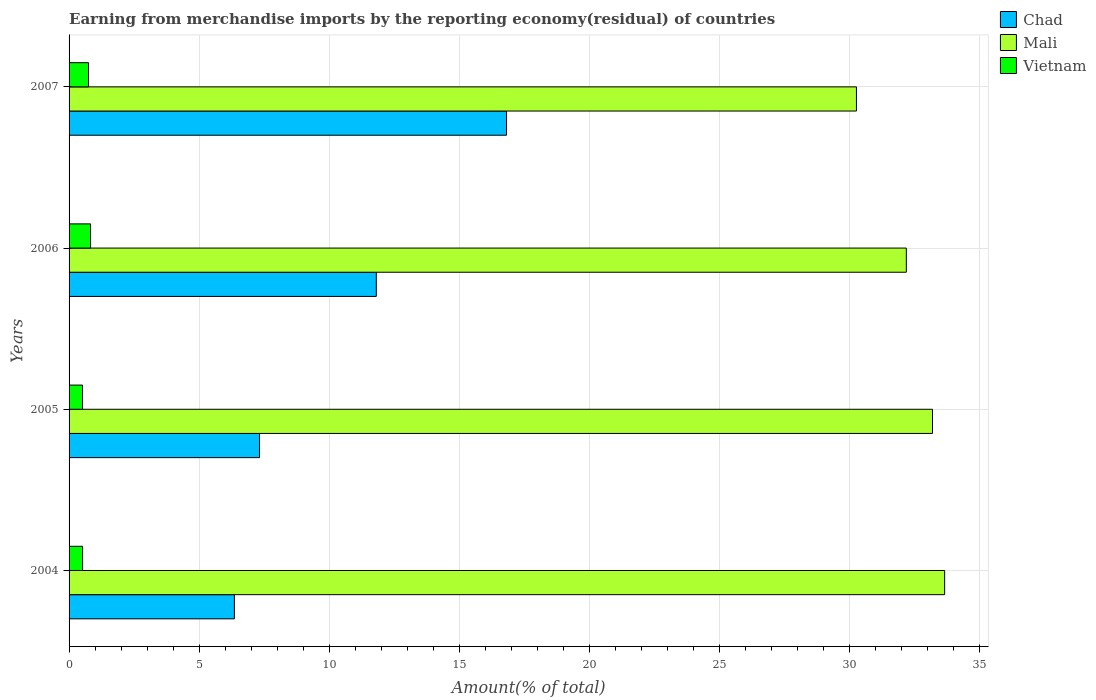How many groups of bars are there?
Your answer should be compact. 4. Are the number of bars per tick equal to the number of legend labels?
Your response must be concise. Yes. Are the number of bars on each tick of the Y-axis equal?
Ensure brevity in your answer.  Yes. In how many cases, is the number of bars for a given year not equal to the number of legend labels?
Ensure brevity in your answer.  0. What is the percentage of amount earned from merchandise imports in Chad in 2005?
Provide a short and direct response. 7.32. Across all years, what is the maximum percentage of amount earned from merchandise imports in Chad?
Offer a very short reply. 16.82. Across all years, what is the minimum percentage of amount earned from merchandise imports in Vietnam?
Your answer should be compact. 0.52. What is the total percentage of amount earned from merchandise imports in Chad in the graph?
Make the answer very short. 42.3. What is the difference between the percentage of amount earned from merchandise imports in Mali in 2004 and that in 2006?
Offer a very short reply. 1.47. What is the difference between the percentage of amount earned from merchandise imports in Chad in 2004 and the percentage of amount earned from merchandise imports in Mali in 2007?
Your response must be concise. -23.91. What is the average percentage of amount earned from merchandise imports in Vietnam per year?
Your response must be concise. 0.65. In the year 2004, what is the difference between the percentage of amount earned from merchandise imports in Mali and percentage of amount earned from merchandise imports in Chad?
Offer a very short reply. 27.3. What is the ratio of the percentage of amount earned from merchandise imports in Chad in 2006 to that in 2007?
Keep it short and to the point. 0.7. Is the percentage of amount earned from merchandise imports in Vietnam in 2004 less than that in 2006?
Provide a short and direct response. Yes. Is the difference between the percentage of amount earned from merchandise imports in Mali in 2005 and 2006 greater than the difference between the percentage of amount earned from merchandise imports in Chad in 2005 and 2006?
Keep it short and to the point. Yes. What is the difference between the highest and the second highest percentage of amount earned from merchandise imports in Vietnam?
Your answer should be compact. 0.08. What is the difference between the highest and the lowest percentage of amount earned from merchandise imports in Vietnam?
Your answer should be compact. 0.31. Is the sum of the percentage of amount earned from merchandise imports in Mali in 2005 and 2007 greater than the maximum percentage of amount earned from merchandise imports in Vietnam across all years?
Ensure brevity in your answer.  Yes. What does the 2nd bar from the top in 2004 represents?
Provide a short and direct response. Mali. What does the 3rd bar from the bottom in 2006 represents?
Your answer should be very brief. Vietnam. How many bars are there?
Offer a very short reply. 12. Are all the bars in the graph horizontal?
Provide a succinct answer. Yes. Are the values on the major ticks of X-axis written in scientific E-notation?
Provide a short and direct response. No. Does the graph contain grids?
Offer a very short reply. Yes. How many legend labels are there?
Provide a short and direct response. 3. How are the legend labels stacked?
Give a very brief answer. Vertical. What is the title of the graph?
Ensure brevity in your answer.  Earning from merchandise imports by the reporting economy(residual) of countries. Does "Liechtenstein" appear as one of the legend labels in the graph?
Offer a very short reply. No. What is the label or title of the X-axis?
Offer a terse response. Amount(% of total). What is the label or title of the Y-axis?
Offer a very short reply. Years. What is the Amount(% of total) in Chad in 2004?
Provide a short and direct response. 6.35. What is the Amount(% of total) in Mali in 2004?
Provide a succinct answer. 33.65. What is the Amount(% of total) in Vietnam in 2004?
Your answer should be compact. 0.52. What is the Amount(% of total) in Chad in 2005?
Keep it short and to the point. 7.32. What is the Amount(% of total) in Mali in 2005?
Provide a succinct answer. 33.19. What is the Amount(% of total) of Vietnam in 2005?
Your answer should be very brief. 0.52. What is the Amount(% of total) of Chad in 2006?
Your answer should be compact. 11.81. What is the Amount(% of total) in Mali in 2006?
Keep it short and to the point. 32.18. What is the Amount(% of total) of Vietnam in 2006?
Your answer should be compact. 0.83. What is the Amount(% of total) in Chad in 2007?
Ensure brevity in your answer.  16.82. What is the Amount(% of total) of Mali in 2007?
Make the answer very short. 30.26. What is the Amount(% of total) of Vietnam in 2007?
Your answer should be compact. 0.75. Across all years, what is the maximum Amount(% of total) in Chad?
Your response must be concise. 16.82. Across all years, what is the maximum Amount(% of total) of Mali?
Give a very brief answer. 33.65. Across all years, what is the maximum Amount(% of total) in Vietnam?
Provide a succinct answer. 0.83. Across all years, what is the minimum Amount(% of total) of Chad?
Provide a short and direct response. 6.35. Across all years, what is the minimum Amount(% of total) in Mali?
Keep it short and to the point. 30.26. Across all years, what is the minimum Amount(% of total) in Vietnam?
Your response must be concise. 0.52. What is the total Amount(% of total) in Chad in the graph?
Your answer should be very brief. 42.3. What is the total Amount(% of total) in Mali in the graph?
Offer a terse response. 129.29. What is the total Amount(% of total) of Vietnam in the graph?
Provide a succinct answer. 2.61. What is the difference between the Amount(% of total) in Chad in 2004 and that in 2005?
Your answer should be very brief. -0.97. What is the difference between the Amount(% of total) of Mali in 2004 and that in 2005?
Provide a succinct answer. 0.47. What is the difference between the Amount(% of total) in Vietnam in 2004 and that in 2005?
Give a very brief answer. 0. What is the difference between the Amount(% of total) of Chad in 2004 and that in 2006?
Make the answer very short. -5.46. What is the difference between the Amount(% of total) of Mali in 2004 and that in 2006?
Your answer should be very brief. 1.47. What is the difference between the Amount(% of total) of Vietnam in 2004 and that in 2006?
Provide a succinct answer. -0.31. What is the difference between the Amount(% of total) of Chad in 2004 and that in 2007?
Give a very brief answer. -10.46. What is the difference between the Amount(% of total) in Mali in 2004 and that in 2007?
Make the answer very short. 3.39. What is the difference between the Amount(% of total) in Vietnam in 2004 and that in 2007?
Your answer should be very brief. -0.23. What is the difference between the Amount(% of total) in Chad in 2005 and that in 2006?
Ensure brevity in your answer.  -4.49. What is the difference between the Amount(% of total) in Mali in 2005 and that in 2006?
Provide a succinct answer. 1.01. What is the difference between the Amount(% of total) in Vietnam in 2005 and that in 2006?
Make the answer very short. -0.31. What is the difference between the Amount(% of total) in Chad in 2005 and that in 2007?
Your response must be concise. -9.5. What is the difference between the Amount(% of total) of Mali in 2005 and that in 2007?
Give a very brief answer. 2.92. What is the difference between the Amount(% of total) in Vietnam in 2005 and that in 2007?
Offer a very short reply. -0.23. What is the difference between the Amount(% of total) of Chad in 2006 and that in 2007?
Keep it short and to the point. -5.01. What is the difference between the Amount(% of total) in Mali in 2006 and that in 2007?
Offer a terse response. 1.92. What is the difference between the Amount(% of total) in Vietnam in 2006 and that in 2007?
Your answer should be compact. 0.08. What is the difference between the Amount(% of total) of Chad in 2004 and the Amount(% of total) of Mali in 2005?
Ensure brevity in your answer.  -26.83. What is the difference between the Amount(% of total) in Chad in 2004 and the Amount(% of total) in Vietnam in 2005?
Provide a short and direct response. 5.84. What is the difference between the Amount(% of total) of Mali in 2004 and the Amount(% of total) of Vietnam in 2005?
Offer a very short reply. 33.14. What is the difference between the Amount(% of total) of Chad in 2004 and the Amount(% of total) of Mali in 2006?
Offer a terse response. -25.83. What is the difference between the Amount(% of total) in Chad in 2004 and the Amount(% of total) in Vietnam in 2006?
Your answer should be compact. 5.53. What is the difference between the Amount(% of total) in Mali in 2004 and the Amount(% of total) in Vietnam in 2006?
Offer a terse response. 32.83. What is the difference between the Amount(% of total) in Chad in 2004 and the Amount(% of total) in Mali in 2007?
Provide a succinct answer. -23.91. What is the difference between the Amount(% of total) in Chad in 2004 and the Amount(% of total) in Vietnam in 2007?
Give a very brief answer. 5.61. What is the difference between the Amount(% of total) of Mali in 2004 and the Amount(% of total) of Vietnam in 2007?
Your response must be concise. 32.91. What is the difference between the Amount(% of total) of Chad in 2005 and the Amount(% of total) of Mali in 2006?
Offer a very short reply. -24.86. What is the difference between the Amount(% of total) in Chad in 2005 and the Amount(% of total) in Vietnam in 2006?
Provide a succinct answer. 6.49. What is the difference between the Amount(% of total) of Mali in 2005 and the Amount(% of total) of Vietnam in 2006?
Offer a very short reply. 32.36. What is the difference between the Amount(% of total) of Chad in 2005 and the Amount(% of total) of Mali in 2007?
Provide a short and direct response. -22.94. What is the difference between the Amount(% of total) in Chad in 2005 and the Amount(% of total) in Vietnam in 2007?
Your answer should be compact. 6.57. What is the difference between the Amount(% of total) in Mali in 2005 and the Amount(% of total) in Vietnam in 2007?
Provide a succinct answer. 32.44. What is the difference between the Amount(% of total) of Chad in 2006 and the Amount(% of total) of Mali in 2007?
Provide a short and direct response. -18.45. What is the difference between the Amount(% of total) of Chad in 2006 and the Amount(% of total) of Vietnam in 2007?
Offer a very short reply. 11.06. What is the difference between the Amount(% of total) in Mali in 2006 and the Amount(% of total) in Vietnam in 2007?
Provide a short and direct response. 31.43. What is the average Amount(% of total) of Chad per year?
Provide a short and direct response. 10.57. What is the average Amount(% of total) in Mali per year?
Offer a terse response. 32.32. What is the average Amount(% of total) in Vietnam per year?
Your response must be concise. 0.65. In the year 2004, what is the difference between the Amount(% of total) in Chad and Amount(% of total) in Mali?
Offer a very short reply. -27.3. In the year 2004, what is the difference between the Amount(% of total) in Chad and Amount(% of total) in Vietnam?
Your response must be concise. 5.83. In the year 2004, what is the difference between the Amount(% of total) of Mali and Amount(% of total) of Vietnam?
Provide a short and direct response. 33.13. In the year 2005, what is the difference between the Amount(% of total) of Chad and Amount(% of total) of Mali?
Your answer should be very brief. -25.87. In the year 2005, what is the difference between the Amount(% of total) in Chad and Amount(% of total) in Vietnam?
Keep it short and to the point. 6.8. In the year 2005, what is the difference between the Amount(% of total) in Mali and Amount(% of total) in Vietnam?
Give a very brief answer. 32.67. In the year 2006, what is the difference between the Amount(% of total) in Chad and Amount(% of total) in Mali?
Give a very brief answer. -20.37. In the year 2006, what is the difference between the Amount(% of total) in Chad and Amount(% of total) in Vietnam?
Keep it short and to the point. 10.98. In the year 2006, what is the difference between the Amount(% of total) of Mali and Amount(% of total) of Vietnam?
Offer a very short reply. 31.36. In the year 2007, what is the difference between the Amount(% of total) of Chad and Amount(% of total) of Mali?
Offer a terse response. -13.45. In the year 2007, what is the difference between the Amount(% of total) of Chad and Amount(% of total) of Vietnam?
Make the answer very short. 16.07. In the year 2007, what is the difference between the Amount(% of total) in Mali and Amount(% of total) in Vietnam?
Your answer should be very brief. 29.52. What is the ratio of the Amount(% of total) in Chad in 2004 to that in 2005?
Provide a succinct answer. 0.87. What is the ratio of the Amount(% of total) of Mali in 2004 to that in 2005?
Provide a short and direct response. 1.01. What is the ratio of the Amount(% of total) in Vietnam in 2004 to that in 2005?
Provide a short and direct response. 1. What is the ratio of the Amount(% of total) of Chad in 2004 to that in 2006?
Provide a succinct answer. 0.54. What is the ratio of the Amount(% of total) in Mali in 2004 to that in 2006?
Keep it short and to the point. 1.05. What is the ratio of the Amount(% of total) in Vietnam in 2004 to that in 2006?
Your answer should be very brief. 0.63. What is the ratio of the Amount(% of total) in Chad in 2004 to that in 2007?
Your answer should be compact. 0.38. What is the ratio of the Amount(% of total) in Mali in 2004 to that in 2007?
Ensure brevity in your answer.  1.11. What is the ratio of the Amount(% of total) of Vietnam in 2004 to that in 2007?
Provide a succinct answer. 0.7. What is the ratio of the Amount(% of total) of Chad in 2005 to that in 2006?
Provide a succinct answer. 0.62. What is the ratio of the Amount(% of total) in Mali in 2005 to that in 2006?
Provide a short and direct response. 1.03. What is the ratio of the Amount(% of total) in Vietnam in 2005 to that in 2006?
Your answer should be very brief. 0.63. What is the ratio of the Amount(% of total) in Chad in 2005 to that in 2007?
Make the answer very short. 0.44. What is the ratio of the Amount(% of total) of Mali in 2005 to that in 2007?
Give a very brief answer. 1.1. What is the ratio of the Amount(% of total) in Vietnam in 2005 to that in 2007?
Your answer should be very brief. 0.69. What is the ratio of the Amount(% of total) in Chad in 2006 to that in 2007?
Provide a short and direct response. 0.7. What is the ratio of the Amount(% of total) of Mali in 2006 to that in 2007?
Keep it short and to the point. 1.06. What is the ratio of the Amount(% of total) in Vietnam in 2006 to that in 2007?
Give a very brief answer. 1.11. What is the difference between the highest and the second highest Amount(% of total) of Chad?
Provide a succinct answer. 5.01. What is the difference between the highest and the second highest Amount(% of total) in Mali?
Provide a short and direct response. 0.47. What is the difference between the highest and the second highest Amount(% of total) in Vietnam?
Ensure brevity in your answer.  0.08. What is the difference between the highest and the lowest Amount(% of total) in Chad?
Give a very brief answer. 10.46. What is the difference between the highest and the lowest Amount(% of total) in Mali?
Provide a short and direct response. 3.39. What is the difference between the highest and the lowest Amount(% of total) of Vietnam?
Make the answer very short. 0.31. 